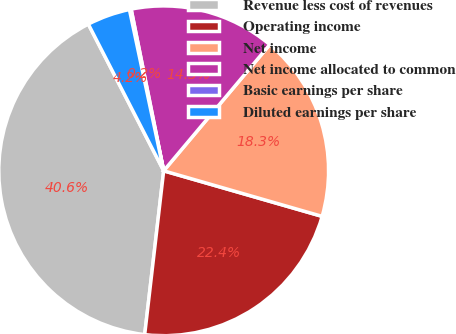Convert chart to OTSL. <chart><loc_0><loc_0><loc_500><loc_500><pie_chart><fcel>Revenue less cost of revenues<fcel>Operating income<fcel>Net income<fcel>Net income allocated to common<fcel>Basic earnings per share<fcel>Diluted earnings per share<nl><fcel>40.61%<fcel>22.38%<fcel>18.33%<fcel>14.29%<fcel>0.17%<fcel>4.22%<nl></chart> 